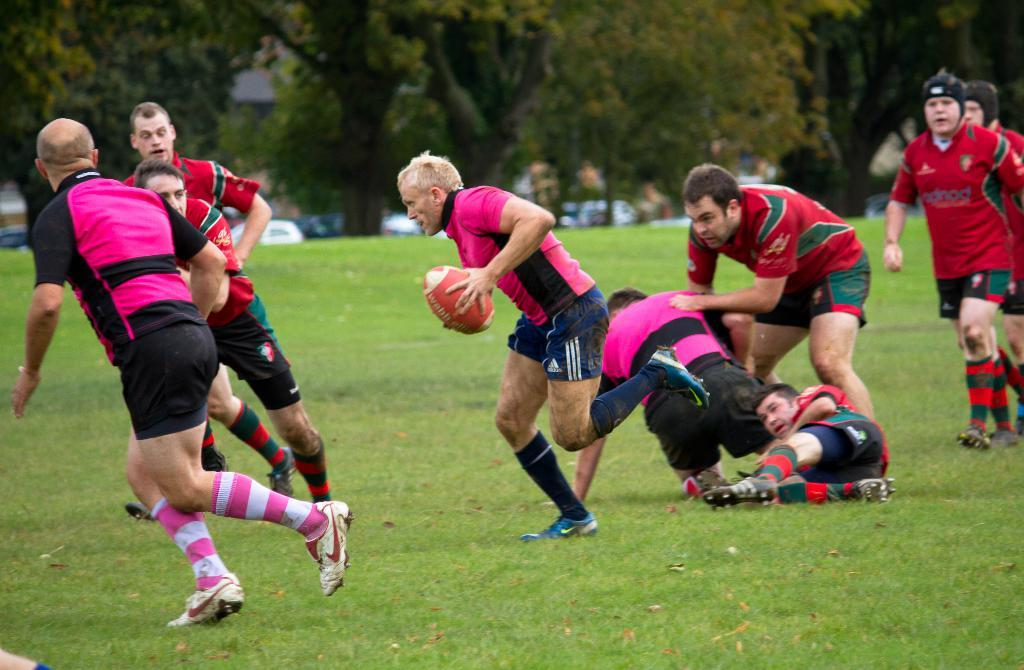How many people are in the image? There are people in the image, but the exact number is not specified. What are the people wearing in the image? The people are wearing sports dress in the image. What activity are the people engaged in? The people are playing a game in the image. What object is one of the people holding? One of the people is holding a ball in the image. What can be seen in the background of the image? There are trees in the background of the image. What is visible at the bottom of the image? There is ground visible at the bottom of the image. What type of bushes can be seen growing on the range in the image? There are no bushes or range present in the image; it features people playing a game with a ball. Who is wearing the crown in the image? There is no crown visible in the image. 